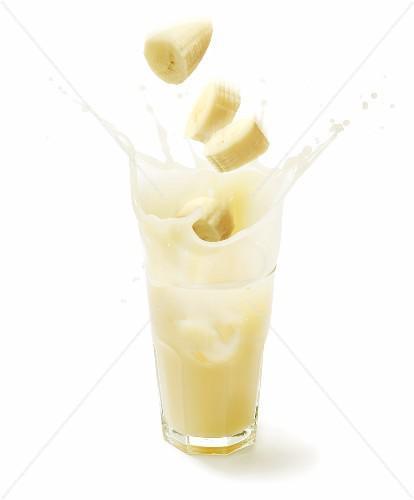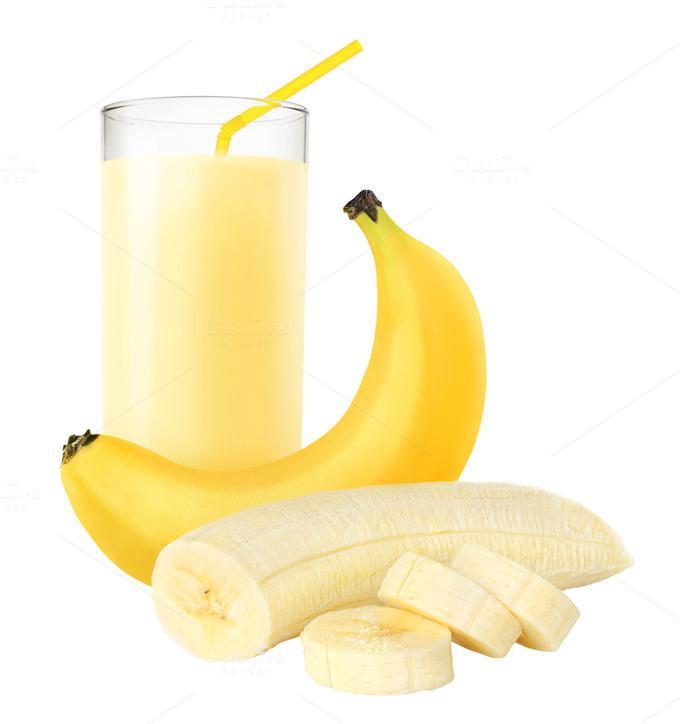The first image is the image on the left, the second image is the image on the right. Given the left and right images, does the statement "There are pieces of bananas without peel near a glass of juice." hold true? Answer yes or no. Yes. The first image is the image on the left, the second image is the image on the right. Analyze the images presented: Is the assertion "The right image contains at least one unpeeled banana." valid? Answer yes or no. Yes. 